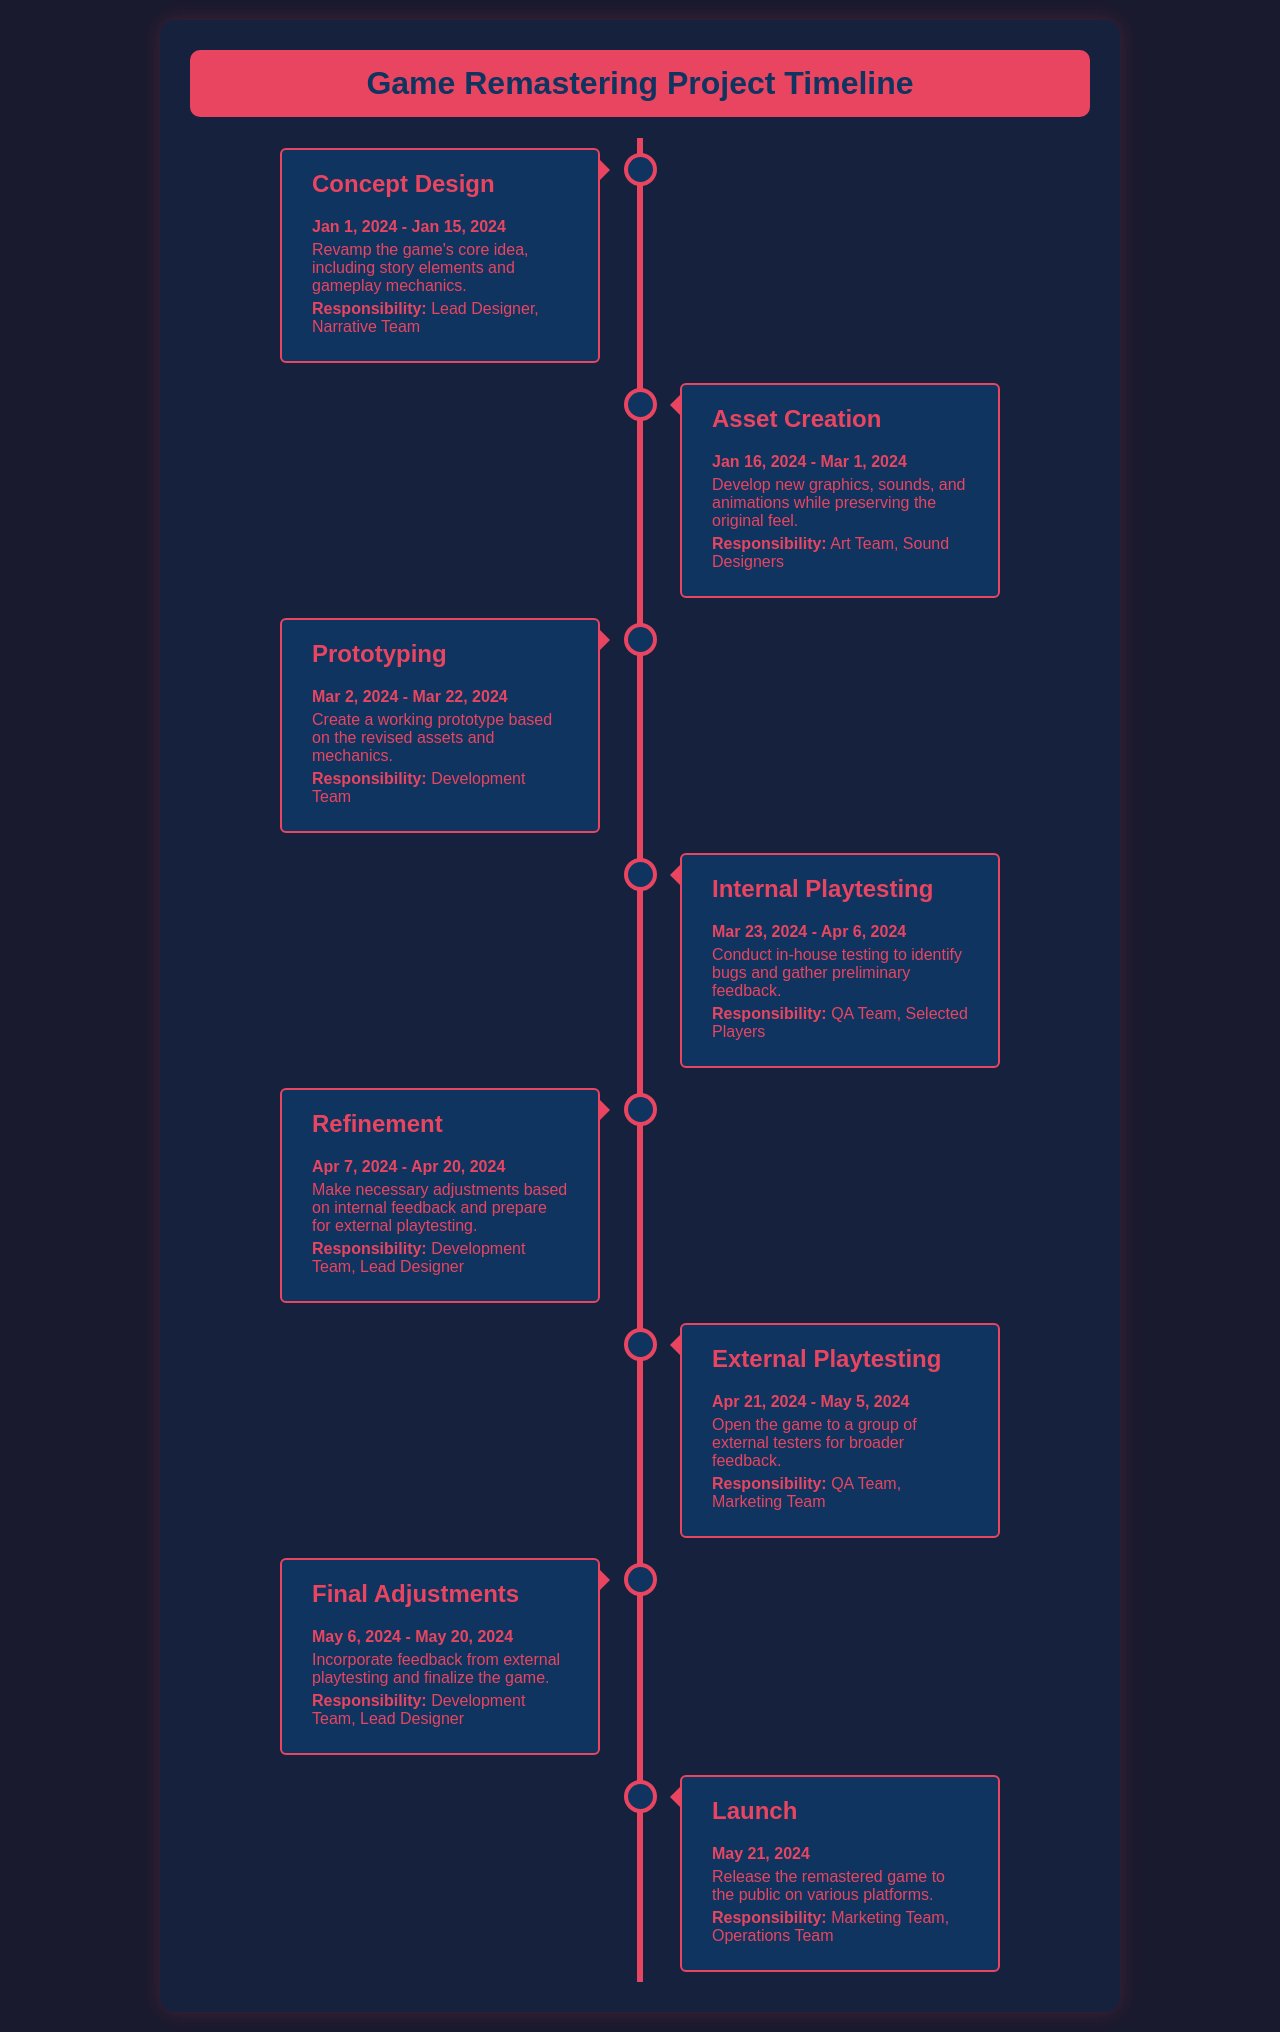What is the first milestone? The first milestone in the document is "Concept Design," which is the initial phase of the project timeline.
Answer: Concept Design What are the dates for Asset Creation? The dates for Asset Creation can be found in the document, indicating when this phase takes place in the project timeline.
Answer: Jan 16, 2024 - Mar 1, 2024 Who is responsible for Prototyping? The document explicitly states the team accountable for Prototyping, which is crucial for understanding the roles in the project.
Answer: Development Team What is the duration of Internal Playtesting? To determine how long Internal Playtesting lasts, one can refer to the dates mentioned for this particular milestone.
Answer: Mar 23, 2024 - Apr 6, 2024 What activity occurs during the Refinement phase? This question asks for a specific task highlighted in the document, related to the phase of Refinement.
Answer: Make necessary adjustments based on internal feedback How many total phases are listed in the timeline? The document contains several milestones that together form the structure of the timeline, which can be counted for a total.
Answer: 7 What is the release date for the Launch? The document provides a specific date for when the Launch occurs, a critical point in the project schedule.
Answer: May 21, 2024 What is the responsibility of the Marketing Team during the Launch? This question requests the specific task of the Marketing Team during the launch, as outlined in the responsibilities section of the document.
Answer: Release the remastered game to the public What follows External Playtesting in the timeline? Identifying what comes after External Playtesting in the schedule requires knowledge of the sequential phases listed in the document.
Answer: Final Adjustments 